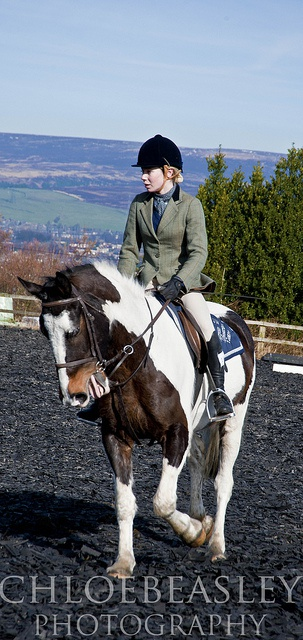Describe the objects in this image and their specific colors. I can see horse in lightblue, black, lightgray, and gray tones and people in lightblue, black, darkgray, gray, and lightgray tones in this image. 